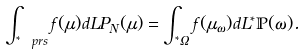Convert formula to latex. <formula><loc_0><loc_0><loc_500><loc_500>\int _ { { ^ { * } } \ p r s } f ( \mu ) d L P _ { N } ( \mu ) = \int _ { { ^ { * } } \Omega } f ( \mu _ { \omega } ) d L { ^ { * } } \mathbb { P } ( \omega ) .</formula> 